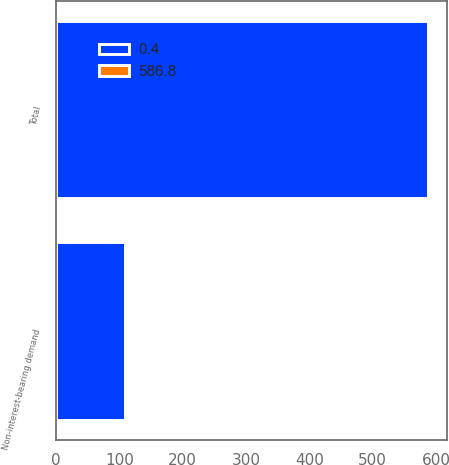Convert chart to OTSL. <chart><loc_0><loc_0><loc_500><loc_500><stacked_bar_chart><ecel><fcel>Non-interest-bearing demand<fcel>Total<nl><fcel>586.8<fcel>0.4<fcel>0.4<nl><fcel>0.4<fcel>108.3<fcel>586.8<nl></chart> 